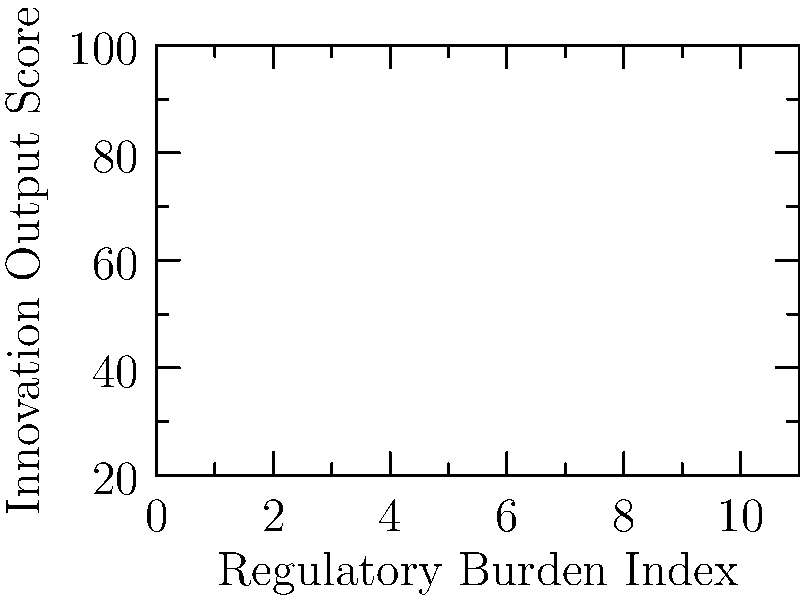Based on the scatter plot showing the relationship between regulatory burden and innovation output in tech companies, what trend can be observed, and how might this support the argument against increased regulations in the software industry? To answer this question, let's analyze the scatter plot step-by-step:

1. Observe the axes:
   - X-axis represents the Regulatory Burden Index
   - Y-axis represents the Innovation Output Score

2. Examine the data points:
   - As we move from left to right, the Regulatory Burden Index increases
   - As we move from bottom to top, the Innovation Output Score increases

3. Identify the trend:
   - There is a clear negative correlation between regulatory burden and innovation output
   - As the Regulatory Burden Index increases, the Innovation Output Score decreases

4. Quantify the relationship:
   - The trend appears to be roughly linear
   - For every 1-point increase in Regulatory Burden Index, there's approximately a 7-point decrease in Innovation Output Score

5. Interpret the results:
   - Higher regulatory burden is associated with lower innovation output
   - This suggests that increased regulations may hinder innovation in tech companies

6. Apply to the argument against increased regulations:
   - The data supports the claim that regulations could stifle innovation
   - It provides evidence that stricter regulations might lead to decreased innovation output in the software industry

7. Consider limitations:
   - Correlation does not imply causation
   - Other factors might influence innovation output

The trend observed in the scatter plot supports the argument that proposed regulations could potentially hinder innovation and growth in the software industry by showing a negative correlation between regulatory burden and innovation output.
Answer: Negative correlation between regulatory burden and innovation output, supporting the argument that increased regulations may stifle innovation in the software industry. 